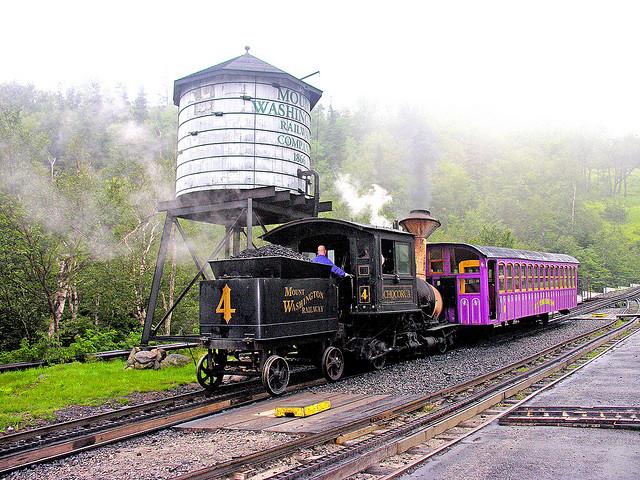What color stands out?
Keep it brief. Purple. What is the number on the left side of the picture?
Be succinct. 4. What number is on the train?
Keep it brief. 4. What is coming out of the engine?
Short answer required. Steam. 